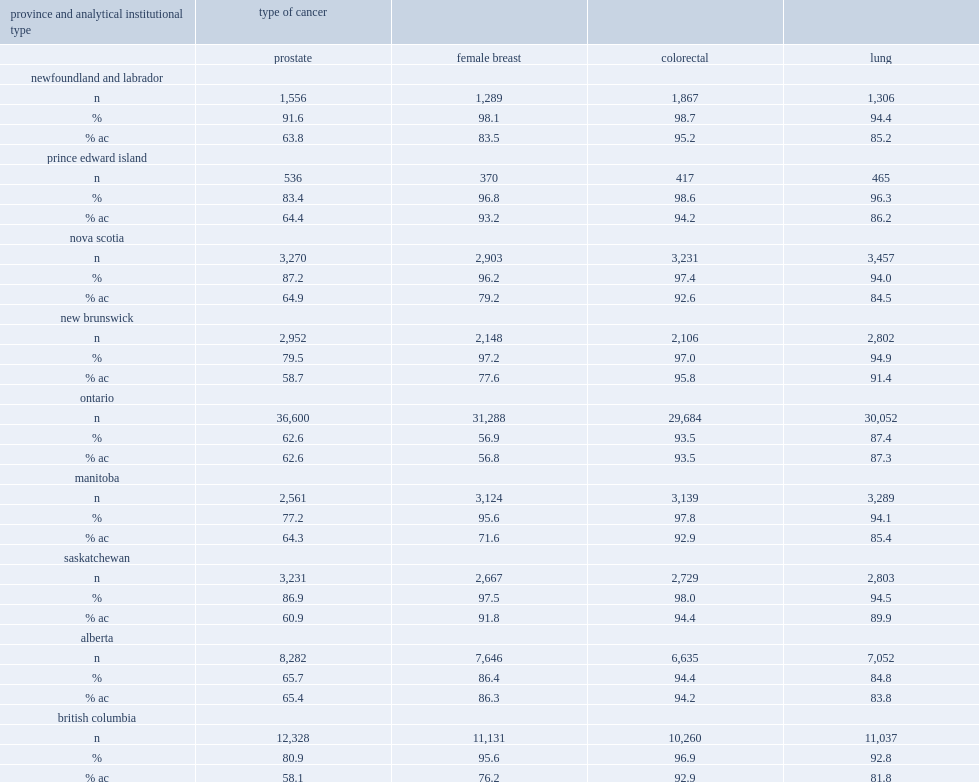What was the range of the percentage of prostate cancers linking to at least one dad record? 77.2 91.6. What was the range of the percentage of prostate cancers limited to dad records submitted by acute care institutions? 58.1 65.4. What was the range of the percentage of female breast cancers linking to at least one dad record? 95.6 98.1. What was the range of the percentage of female breast cancers limited to dad records submitted by acute care institutions? 56.8 93.2. What was the range of the percentage of lung cancers linking to at least one dad record? 92.8 96.3. 